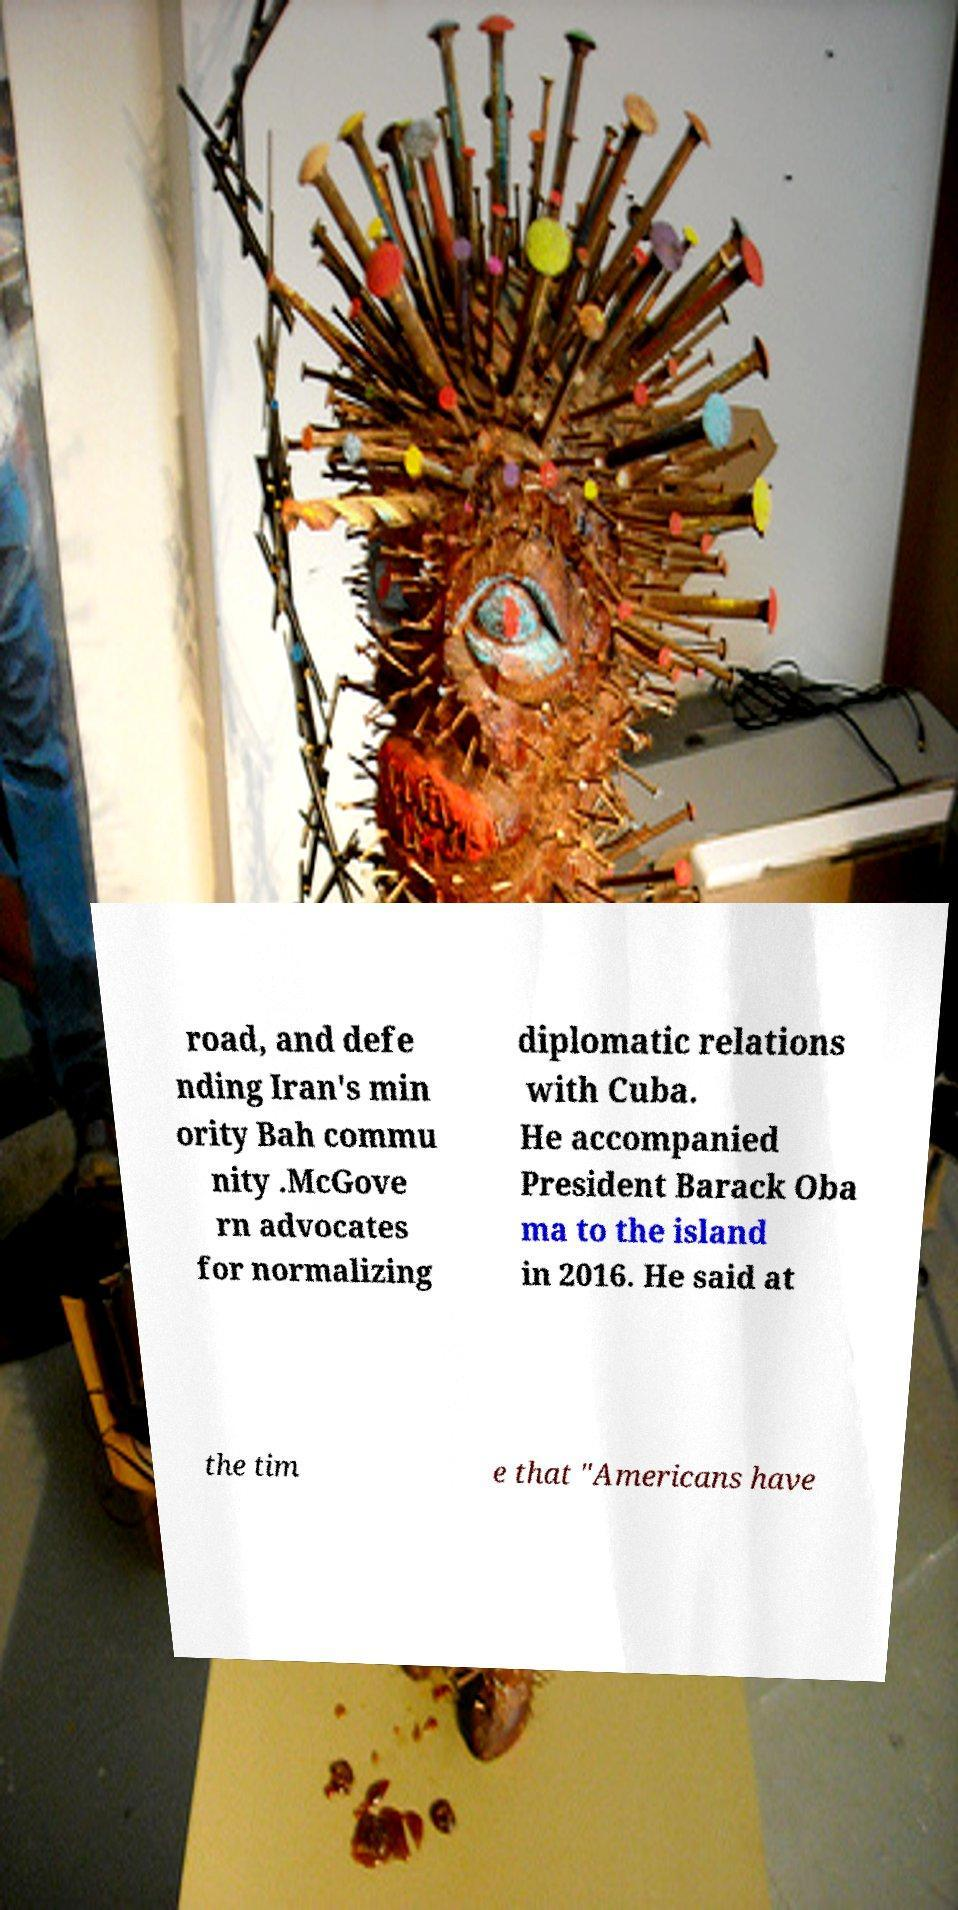Can you read and provide the text displayed in the image?This photo seems to have some interesting text. Can you extract and type it out for me? road, and defe nding Iran's min ority Bah commu nity .McGove rn advocates for normalizing diplomatic relations with Cuba. He accompanied President Barack Oba ma to the island in 2016. He said at the tim e that "Americans have 